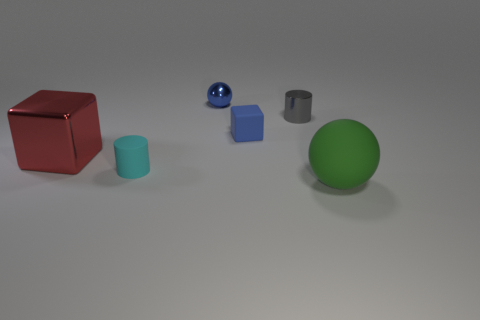Add 4 red metal cubes. How many objects exist? 10 Subtract all large gray rubber cylinders. Subtract all cylinders. How many objects are left? 4 Add 4 tiny cyan things. How many tiny cyan things are left? 5 Add 2 gray shiny things. How many gray shiny things exist? 3 Subtract 1 red cubes. How many objects are left? 5 